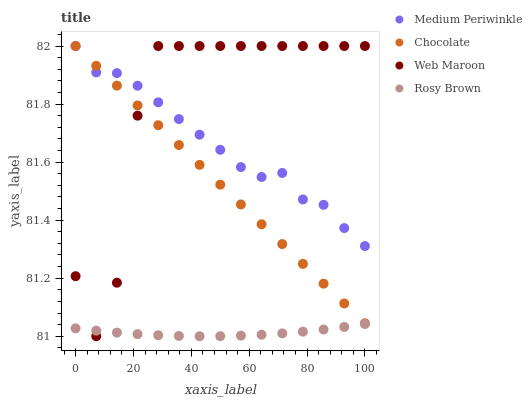Does Rosy Brown have the minimum area under the curve?
Answer yes or no. Yes. Does Web Maroon have the maximum area under the curve?
Answer yes or no. Yes. Does Medium Periwinkle have the minimum area under the curve?
Answer yes or no. No. Does Medium Periwinkle have the maximum area under the curve?
Answer yes or no. No. Is Chocolate the smoothest?
Answer yes or no. Yes. Is Web Maroon the roughest?
Answer yes or no. Yes. Is Rosy Brown the smoothest?
Answer yes or no. No. Is Rosy Brown the roughest?
Answer yes or no. No. Does Rosy Brown have the lowest value?
Answer yes or no. Yes. Does Medium Periwinkle have the lowest value?
Answer yes or no. No. Does Chocolate have the highest value?
Answer yes or no. Yes. Does Rosy Brown have the highest value?
Answer yes or no. No. Is Rosy Brown less than Chocolate?
Answer yes or no. Yes. Is Chocolate greater than Rosy Brown?
Answer yes or no. Yes. Does Web Maroon intersect Medium Periwinkle?
Answer yes or no. Yes. Is Web Maroon less than Medium Periwinkle?
Answer yes or no. No. Is Web Maroon greater than Medium Periwinkle?
Answer yes or no. No. Does Rosy Brown intersect Chocolate?
Answer yes or no. No. 